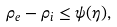<formula> <loc_0><loc_0><loc_500><loc_500>\rho _ { e } - \rho _ { i } \leq \psi ( \eta ) ,</formula> 